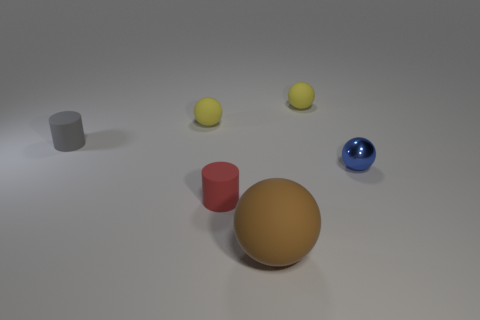Can you tell me about the textures and materials of the objects in this image? Certainly! The objects in the image exhibit a variety of textures and materials. The large foreground sphere has a matte finish suggestive of plastic or painted wood. The shiny blue sphere appears to be made of a glossy material like polished ceramic or glass, reflective, indicating a smooth surface. The red cylinder has a satin-like sheen, also hinting at a plastic material but with a slightly different finish compared to the spheres. Lastly, the small gray object in the background has the fine-grain texture typical of rubber. 